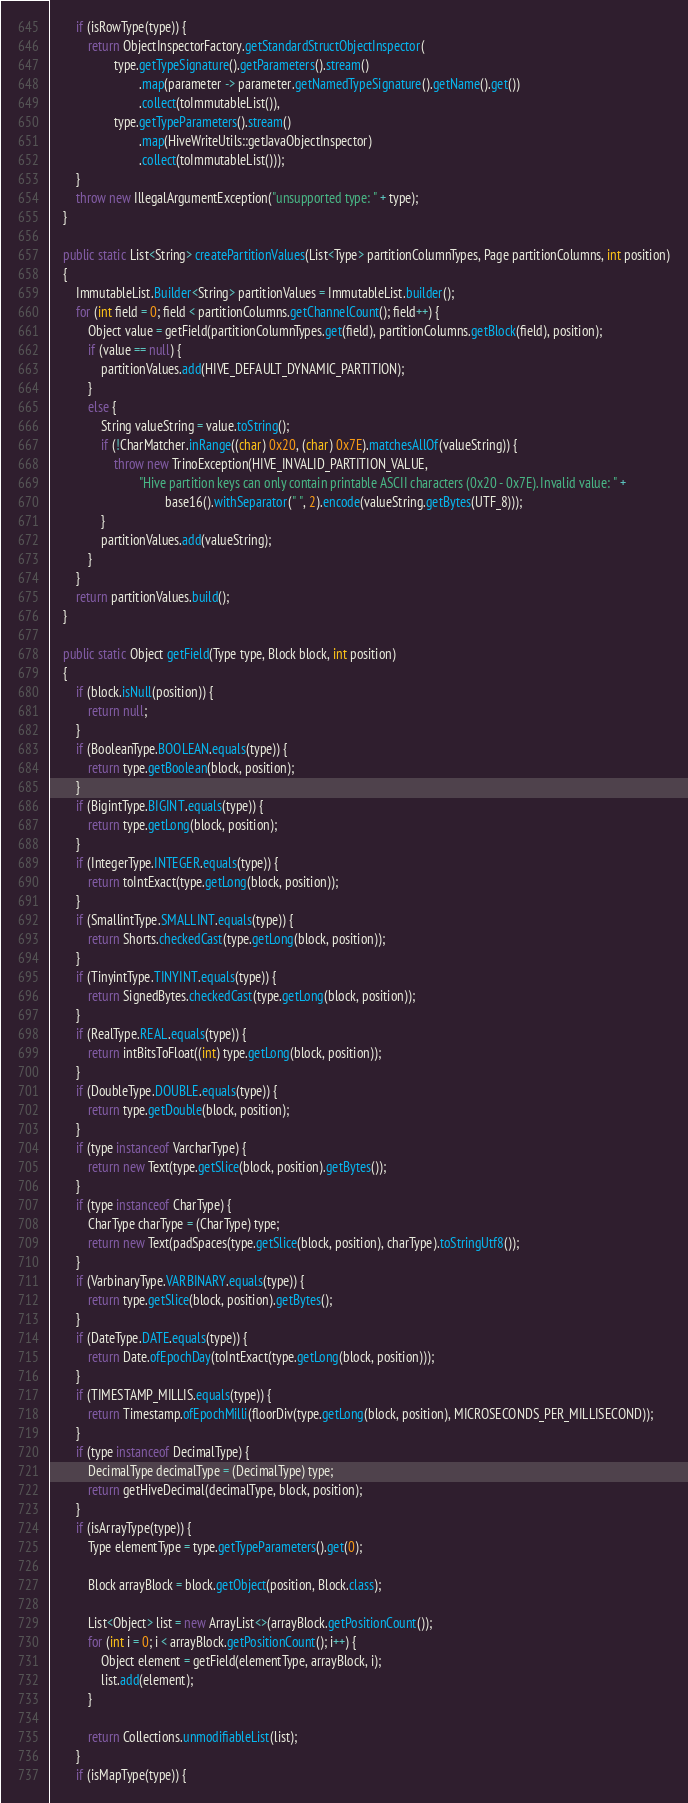Convert code to text. <code><loc_0><loc_0><loc_500><loc_500><_Java_>        if (isRowType(type)) {
            return ObjectInspectorFactory.getStandardStructObjectInspector(
                    type.getTypeSignature().getParameters().stream()
                            .map(parameter -> parameter.getNamedTypeSignature().getName().get())
                            .collect(toImmutableList()),
                    type.getTypeParameters().stream()
                            .map(HiveWriteUtils::getJavaObjectInspector)
                            .collect(toImmutableList()));
        }
        throw new IllegalArgumentException("unsupported type: " + type);
    }

    public static List<String> createPartitionValues(List<Type> partitionColumnTypes, Page partitionColumns, int position)
    {
        ImmutableList.Builder<String> partitionValues = ImmutableList.builder();
        for (int field = 0; field < partitionColumns.getChannelCount(); field++) {
            Object value = getField(partitionColumnTypes.get(field), partitionColumns.getBlock(field), position);
            if (value == null) {
                partitionValues.add(HIVE_DEFAULT_DYNAMIC_PARTITION);
            }
            else {
                String valueString = value.toString();
                if (!CharMatcher.inRange((char) 0x20, (char) 0x7E).matchesAllOf(valueString)) {
                    throw new TrinoException(HIVE_INVALID_PARTITION_VALUE,
                            "Hive partition keys can only contain printable ASCII characters (0x20 - 0x7E). Invalid value: " +
                                    base16().withSeparator(" ", 2).encode(valueString.getBytes(UTF_8)));
                }
                partitionValues.add(valueString);
            }
        }
        return partitionValues.build();
    }

    public static Object getField(Type type, Block block, int position)
    {
        if (block.isNull(position)) {
            return null;
        }
        if (BooleanType.BOOLEAN.equals(type)) {
            return type.getBoolean(block, position);
        }
        if (BigintType.BIGINT.equals(type)) {
            return type.getLong(block, position);
        }
        if (IntegerType.INTEGER.equals(type)) {
            return toIntExact(type.getLong(block, position));
        }
        if (SmallintType.SMALLINT.equals(type)) {
            return Shorts.checkedCast(type.getLong(block, position));
        }
        if (TinyintType.TINYINT.equals(type)) {
            return SignedBytes.checkedCast(type.getLong(block, position));
        }
        if (RealType.REAL.equals(type)) {
            return intBitsToFloat((int) type.getLong(block, position));
        }
        if (DoubleType.DOUBLE.equals(type)) {
            return type.getDouble(block, position);
        }
        if (type instanceof VarcharType) {
            return new Text(type.getSlice(block, position).getBytes());
        }
        if (type instanceof CharType) {
            CharType charType = (CharType) type;
            return new Text(padSpaces(type.getSlice(block, position), charType).toStringUtf8());
        }
        if (VarbinaryType.VARBINARY.equals(type)) {
            return type.getSlice(block, position).getBytes();
        }
        if (DateType.DATE.equals(type)) {
            return Date.ofEpochDay(toIntExact(type.getLong(block, position)));
        }
        if (TIMESTAMP_MILLIS.equals(type)) {
            return Timestamp.ofEpochMilli(floorDiv(type.getLong(block, position), MICROSECONDS_PER_MILLISECOND));
        }
        if (type instanceof DecimalType) {
            DecimalType decimalType = (DecimalType) type;
            return getHiveDecimal(decimalType, block, position);
        }
        if (isArrayType(type)) {
            Type elementType = type.getTypeParameters().get(0);

            Block arrayBlock = block.getObject(position, Block.class);

            List<Object> list = new ArrayList<>(arrayBlock.getPositionCount());
            for (int i = 0; i < arrayBlock.getPositionCount(); i++) {
                Object element = getField(elementType, arrayBlock, i);
                list.add(element);
            }

            return Collections.unmodifiableList(list);
        }
        if (isMapType(type)) {</code> 